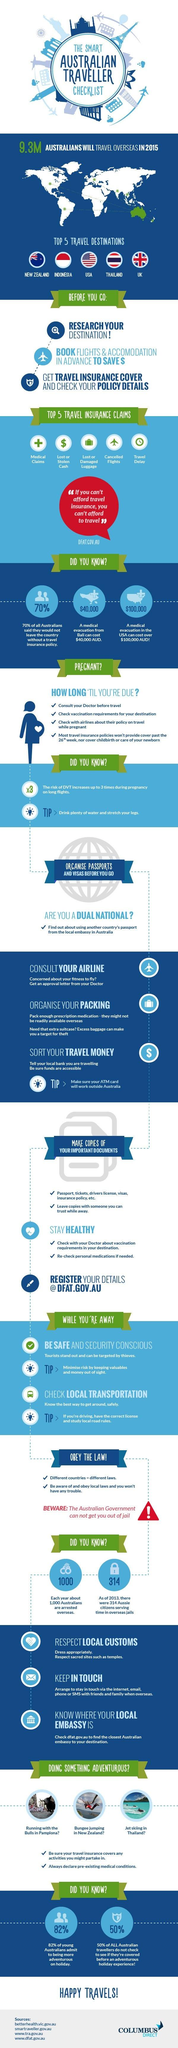Give some essential details in this illustration. According to a recent survey, 18% of young Australians are not adventurous during their holidays. The United States of America has the highest medical evacuation costs among countries. 